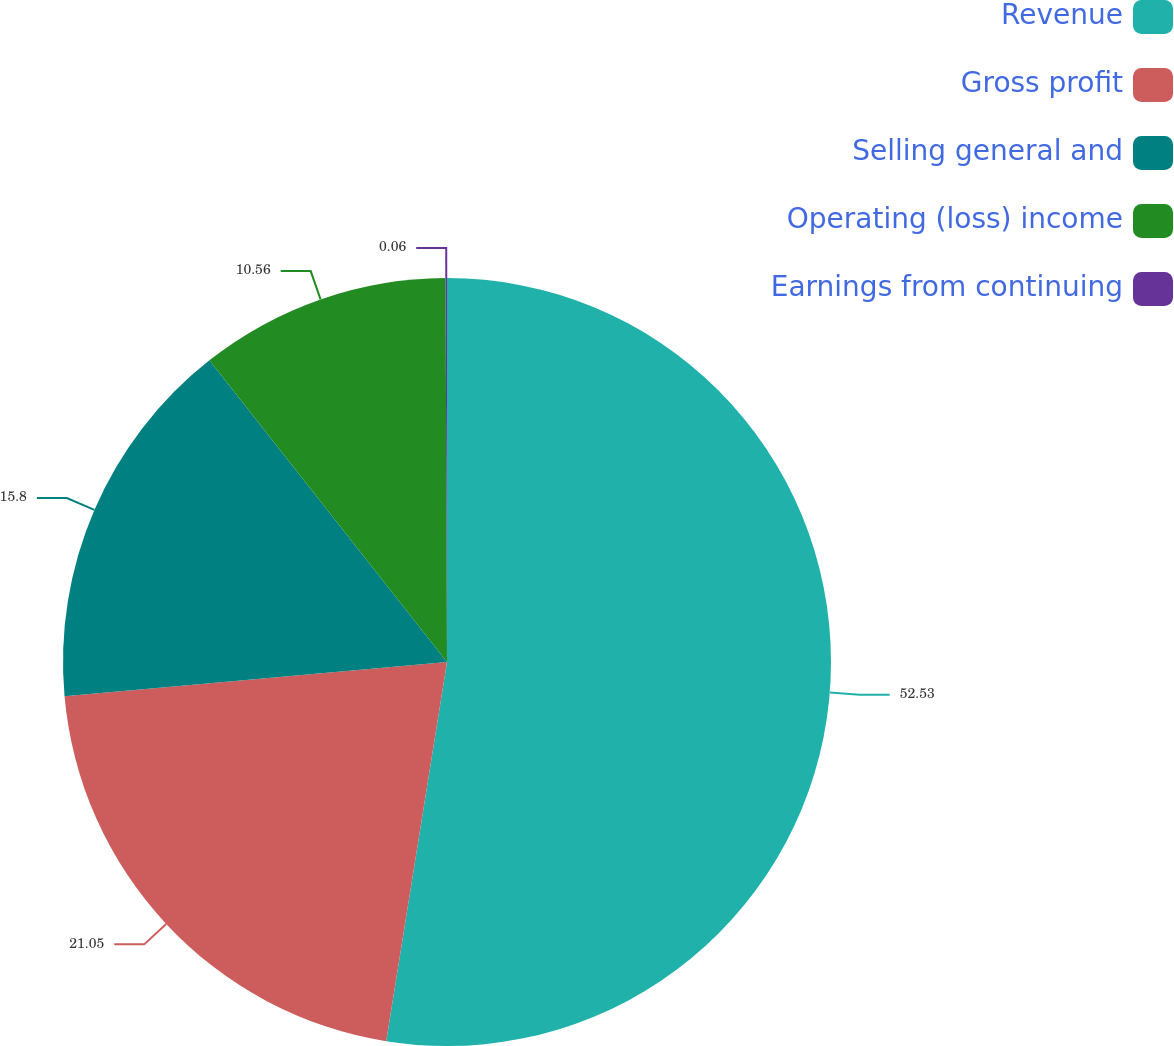Convert chart to OTSL. <chart><loc_0><loc_0><loc_500><loc_500><pie_chart><fcel>Revenue<fcel>Gross profit<fcel>Selling general and<fcel>Operating (loss) income<fcel>Earnings from continuing<nl><fcel>52.53%<fcel>21.05%<fcel>15.8%<fcel>10.56%<fcel>0.06%<nl></chart> 